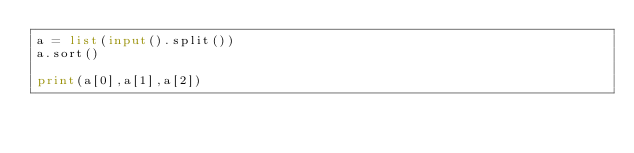Convert code to text. <code><loc_0><loc_0><loc_500><loc_500><_Python_>a = list(input().split())
a.sort()

print(a[0],a[1],a[2])

</code> 